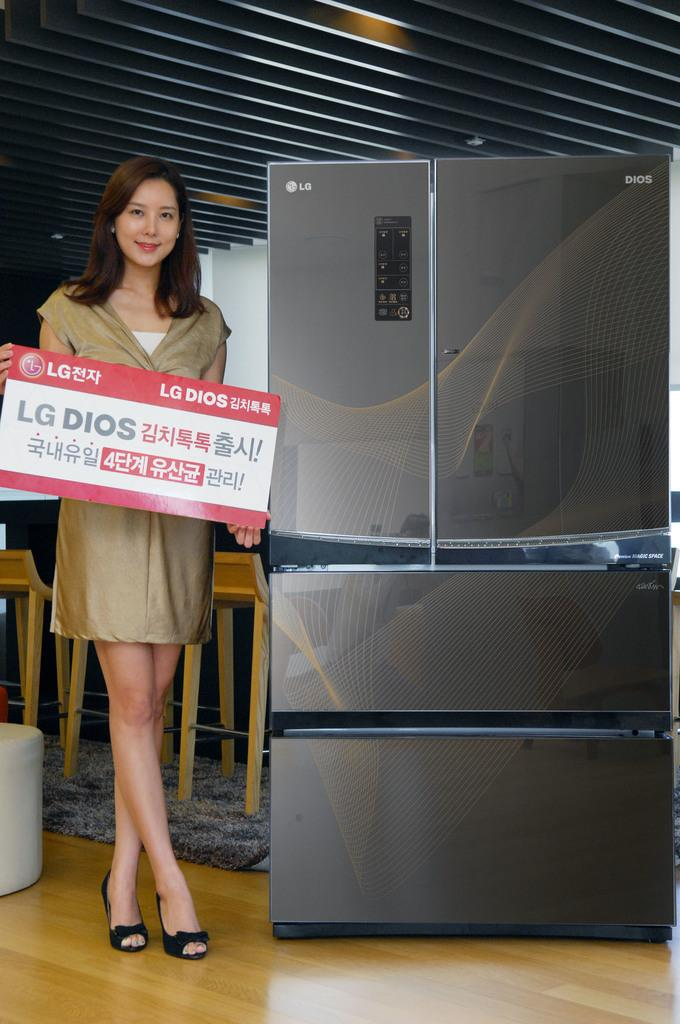<image>
Relay a brief, clear account of the picture shown. A woman standing next to a fridge with an LG logo 